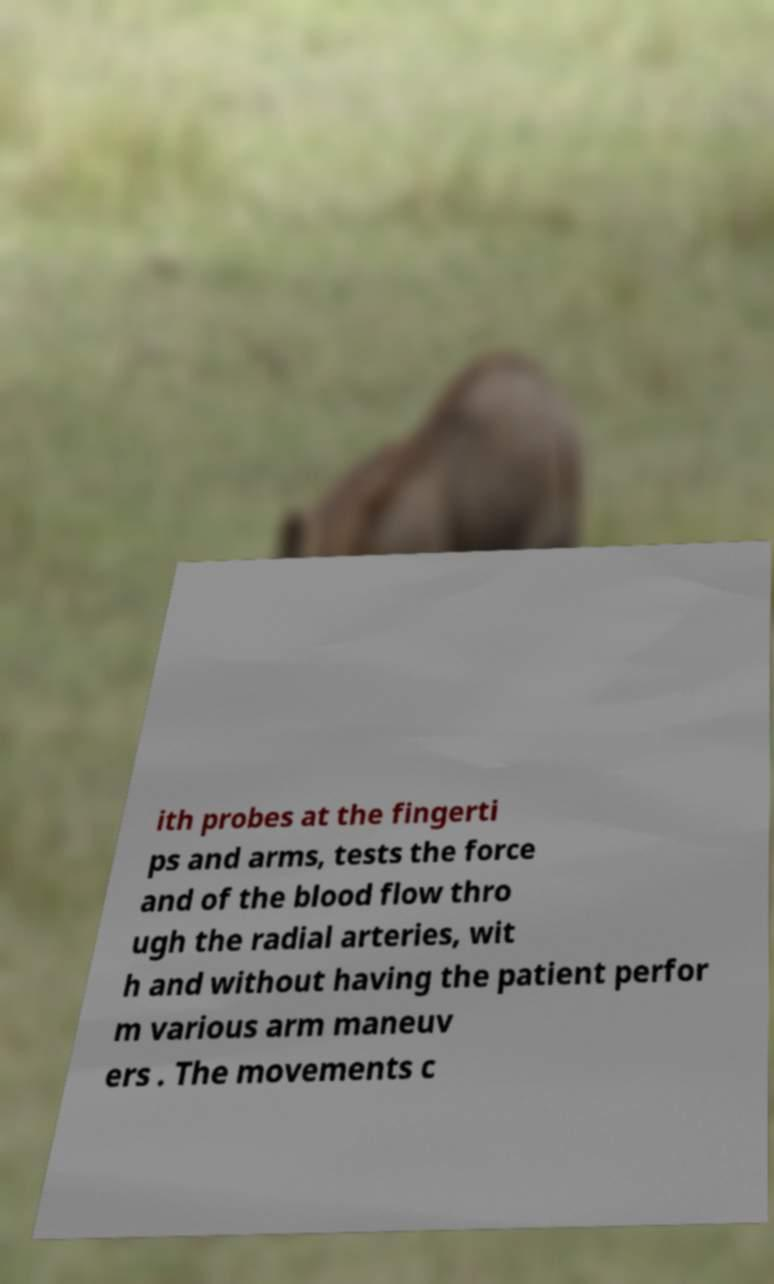There's text embedded in this image that I need extracted. Can you transcribe it verbatim? ith probes at the fingerti ps and arms, tests the force and of the blood flow thro ugh the radial arteries, wit h and without having the patient perfor m various arm maneuv ers . The movements c 